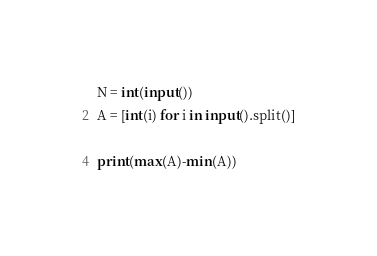<code> <loc_0><loc_0><loc_500><loc_500><_Python_>N = int(input())
A = [int(i) for i in input().split()]

print(max(A)-min(A))</code> 